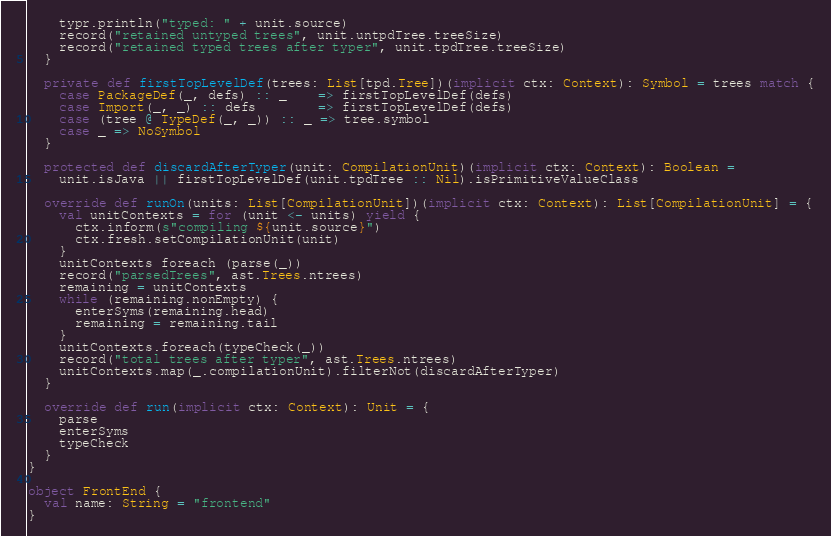Convert code to text. <code><loc_0><loc_0><loc_500><loc_500><_Scala_>    typr.println("typed: " + unit.source)
    record("retained untyped trees", unit.untpdTree.treeSize)
    record("retained typed trees after typer", unit.tpdTree.treeSize)
  }

  private def firstTopLevelDef(trees: List[tpd.Tree])(implicit ctx: Context): Symbol = trees match {
    case PackageDef(_, defs) :: _    => firstTopLevelDef(defs)
    case Import(_, _) :: defs        => firstTopLevelDef(defs)
    case (tree @ TypeDef(_, _)) :: _ => tree.symbol
    case _ => NoSymbol
  }

  protected def discardAfterTyper(unit: CompilationUnit)(implicit ctx: Context): Boolean =
    unit.isJava || firstTopLevelDef(unit.tpdTree :: Nil).isPrimitiveValueClass

  override def runOn(units: List[CompilationUnit])(implicit ctx: Context): List[CompilationUnit] = {
    val unitContexts = for (unit <- units) yield {
      ctx.inform(s"compiling ${unit.source}")
      ctx.fresh.setCompilationUnit(unit)
    }
    unitContexts foreach (parse(_))
    record("parsedTrees", ast.Trees.ntrees)
    remaining = unitContexts
    while (remaining.nonEmpty) {
      enterSyms(remaining.head)
      remaining = remaining.tail
    }
    unitContexts.foreach(typeCheck(_))
    record("total trees after typer", ast.Trees.ntrees)
    unitContexts.map(_.compilationUnit).filterNot(discardAfterTyper)
  }

  override def run(implicit ctx: Context): Unit = {
    parse
    enterSyms
    typeCheck
  }
}

object FrontEnd {
  val name: String = "frontend"
}
</code> 